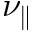<formula> <loc_0><loc_0><loc_500><loc_500>\nu _ { \| }</formula> 